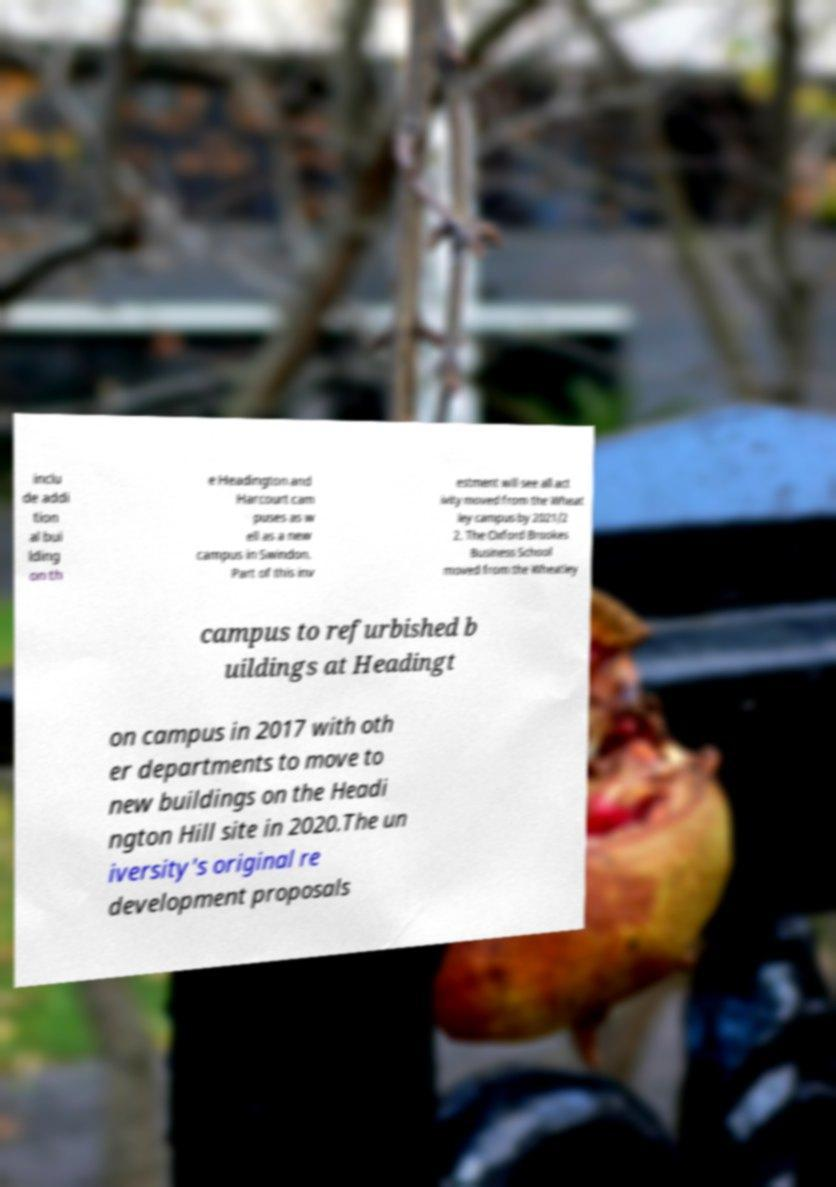Please read and relay the text visible in this image. What does it say? inclu de addi tion al bui lding on th e Headington and Harcourt cam puses as w ell as a new campus in Swindon. Part of this inv estment will see all act ivity moved from the Wheat ley campus by 2021/2 2. The Oxford Brookes Business School moved from the Wheatley campus to refurbished b uildings at Headingt on campus in 2017 with oth er departments to move to new buildings on the Headi ngton Hill site in 2020.The un iversity's original re development proposals 